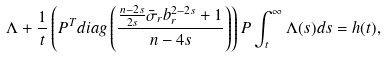Convert formula to latex. <formula><loc_0><loc_0><loc_500><loc_500>\Lambda + \frac { 1 } { t } \left ( P ^ { T } d i a g \left ( \frac { \frac { n - 2 s } { 2 s } \bar { \sigma } _ { r } b _ { r } ^ { 2 - 2 s } + 1 } { n - 4 s } \right ) \right ) P \int _ { t } ^ { \infty } \Lambda ( s ) d s = h ( t ) ,</formula> 